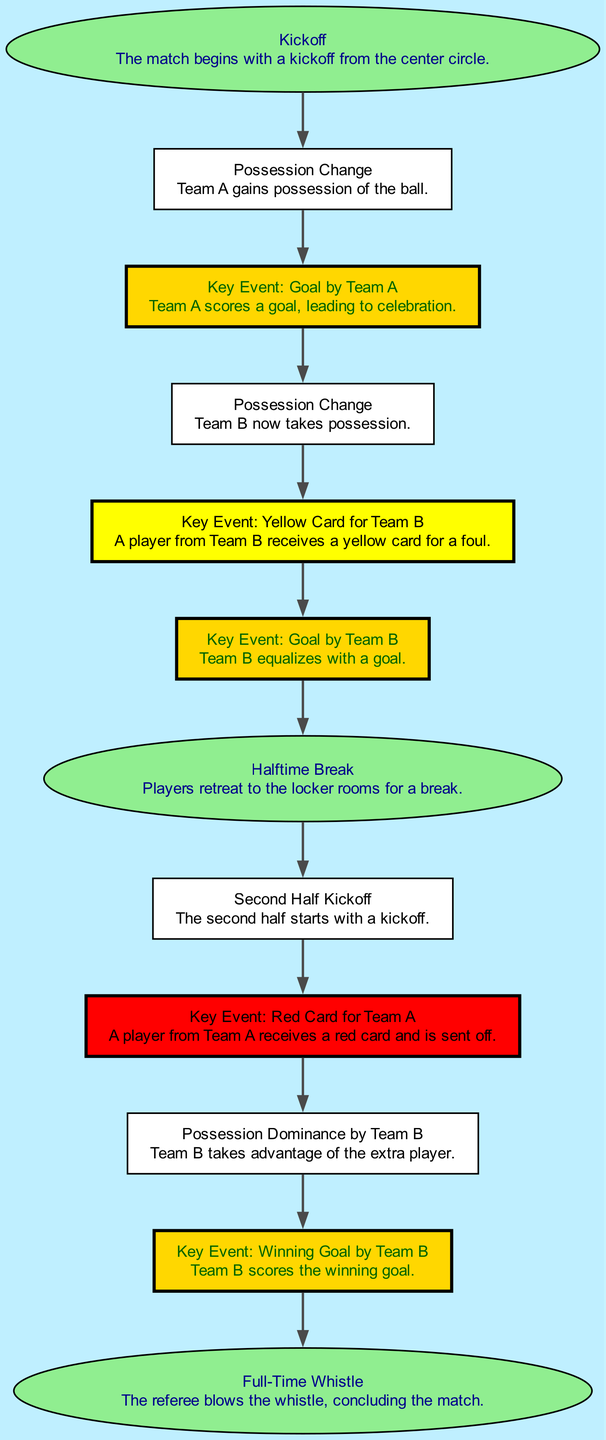What is the first event in the soccer match? The first event listed in the flow chart is "Kickoff," which indicates that the match begins with a kickoff from the center circle.
Answer: Kickoff How many key events are there in the match? By counting the events labeled as "Key Event," it is evident that there are four such events: two goals and two cards.
Answer: 4 Which team scored the first goal? The flow chart indicates that "Key Event: Goal by Team A" occurs before any other goal, therefore Team A scores the first goal.
Answer: Team A What happens after Team A receives a red card? Following "Key Event: Red Card for Team A," the next event listed is "Possession Dominance by Team B," indicating Team B takes advantage of the situation.
Answer: Possession Dominance by Team B What is the last event depicted in the flow chart? The final event in the sequence is "Full-Time Whistle," which concludes the match after all preceding events have occurred.
Answer: Full-Time Whistle Which major event happens at halftime? The event "Halftime Break" occurs at the middle of the match flow, specifically after Team B's goal.
Answer: Halftime Break How does possession change throughout the match? Possession changes multiple times: starts with Team A, then moves to Team B after their first event, and it continues alternating with the events that follow.
Answer: Alternating possession What type of card does Team B receive? The flow chart indicates that "Key Event: Yellow Card for Team B" is the specific card that Team B receives during the match.
Answer: Yellow Card What is indicated by the events after the second half kickoff? After "Second Half Kickoff," the flow shows a red card for Team A, followed by Team B gaining a tactical advantage, leading to their winning goal.
Answer: Winning Goal by Team B 